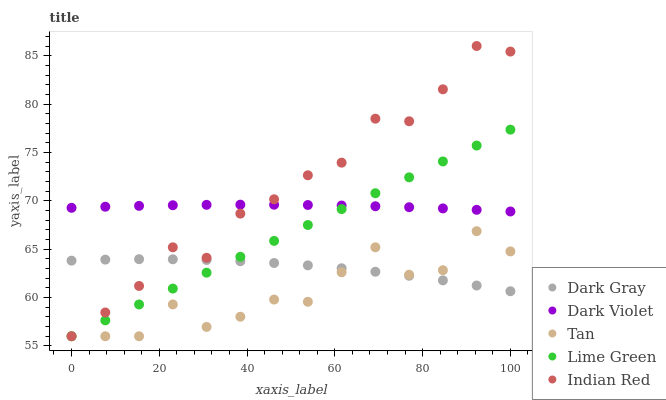Does Tan have the minimum area under the curve?
Answer yes or no. Yes. Does Indian Red have the maximum area under the curve?
Answer yes or no. Yes. Does Lime Green have the minimum area under the curve?
Answer yes or no. No. Does Lime Green have the maximum area under the curve?
Answer yes or no. No. Is Lime Green the smoothest?
Answer yes or no. Yes. Is Tan the roughest?
Answer yes or no. Yes. Is Tan the smoothest?
Answer yes or no. No. Is Lime Green the roughest?
Answer yes or no. No. Does Tan have the lowest value?
Answer yes or no. Yes. Does Dark Violet have the lowest value?
Answer yes or no. No. Does Indian Red have the highest value?
Answer yes or no. Yes. Does Tan have the highest value?
Answer yes or no. No. Is Tan less than Dark Violet?
Answer yes or no. Yes. Is Dark Violet greater than Dark Gray?
Answer yes or no. Yes. Does Dark Violet intersect Lime Green?
Answer yes or no. Yes. Is Dark Violet less than Lime Green?
Answer yes or no. No. Is Dark Violet greater than Lime Green?
Answer yes or no. No. Does Tan intersect Dark Violet?
Answer yes or no. No. 